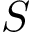Convert formula to latex. <formula><loc_0><loc_0><loc_500><loc_500>S</formula> 